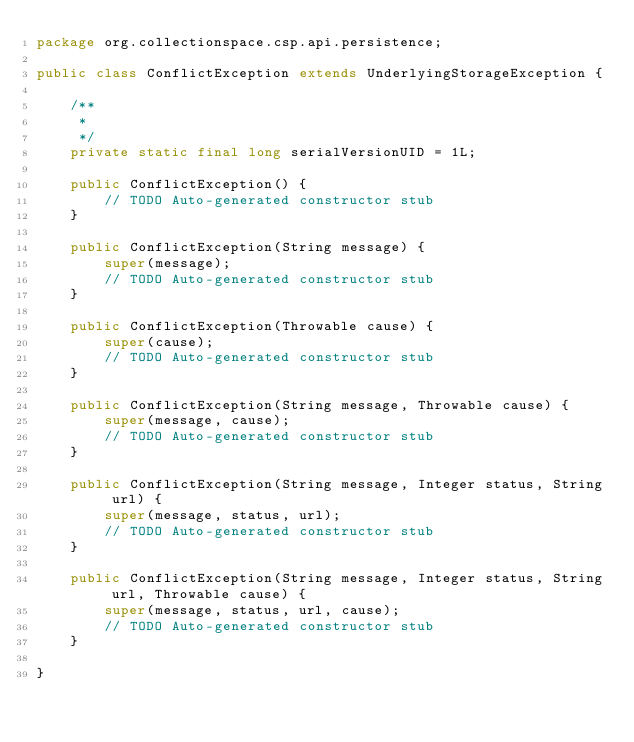<code> <loc_0><loc_0><loc_500><loc_500><_Java_>package org.collectionspace.csp.api.persistence;

public class ConflictException extends UnderlyingStorageException {

	/**
	 * 
	 */
	private static final long serialVersionUID = 1L;

	public ConflictException() {
		// TODO Auto-generated constructor stub
	}

	public ConflictException(String message) {
		super(message);
		// TODO Auto-generated constructor stub
	}

	public ConflictException(Throwable cause) {
		super(cause);
		// TODO Auto-generated constructor stub
	}

	public ConflictException(String message, Throwable cause) {
		super(message, cause);
		// TODO Auto-generated constructor stub
	}

	public ConflictException(String message, Integer status, String url) {
		super(message, status, url);
		// TODO Auto-generated constructor stub
	}

	public ConflictException(String message, Integer status, String url, Throwable cause) {
		super(message, status, url, cause);
		// TODO Auto-generated constructor stub
	}

}
</code> 